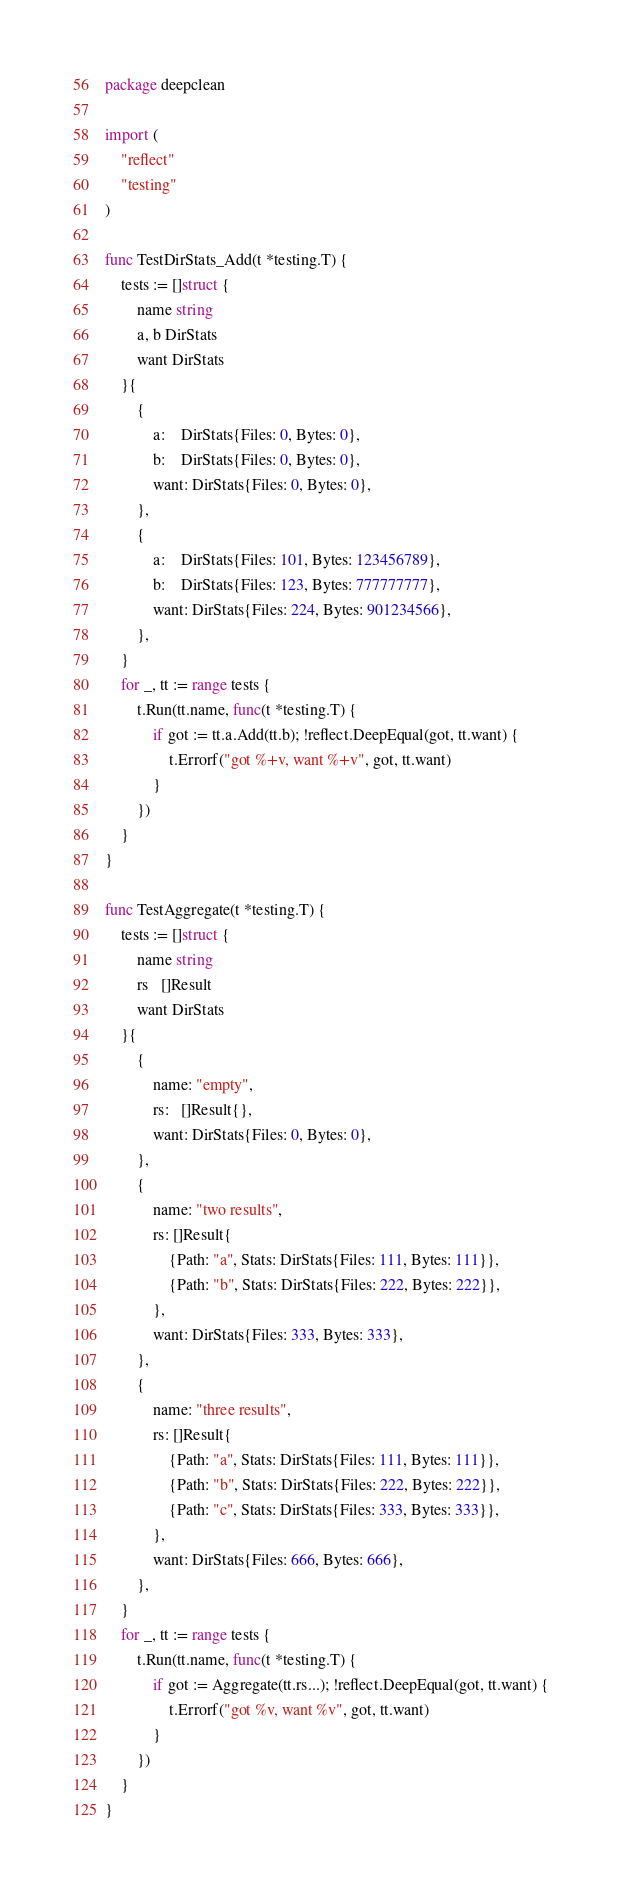<code> <loc_0><loc_0><loc_500><loc_500><_Go_>package deepclean

import (
	"reflect"
	"testing"
)

func TestDirStats_Add(t *testing.T) {
	tests := []struct {
		name string
		a, b DirStats
		want DirStats
	}{
		{
			a:    DirStats{Files: 0, Bytes: 0},
			b:    DirStats{Files: 0, Bytes: 0},
			want: DirStats{Files: 0, Bytes: 0},
		},
		{
			a:    DirStats{Files: 101, Bytes: 123456789},
			b:    DirStats{Files: 123, Bytes: 777777777},
			want: DirStats{Files: 224, Bytes: 901234566},
		},
	}
	for _, tt := range tests {
		t.Run(tt.name, func(t *testing.T) {
			if got := tt.a.Add(tt.b); !reflect.DeepEqual(got, tt.want) {
				t.Errorf("got %+v, want %+v", got, tt.want)
			}
		})
	}
}

func TestAggregate(t *testing.T) {
	tests := []struct {
		name string
		rs   []Result
		want DirStats
	}{
		{
			name: "empty",
			rs:   []Result{},
			want: DirStats{Files: 0, Bytes: 0},
		},
		{
			name: "two results",
			rs: []Result{
				{Path: "a", Stats: DirStats{Files: 111, Bytes: 111}},
				{Path: "b", Stats: DirStats{Files: 222, Bytes: 222}},
			},
			want: DirStats{Files: 333, Bytes: 333},
		},
		{
			name: "three results",
			rs: []Result{
				{Path: "a", Stats: DirStats{Files: 111, Bytes: 111}},
				{Path: "b", Stats: DirStats{Files: 222, Bytes: 222}},
				{Path: "c", Stats: DirStats{Files: 333, Bytes: 333}},
			},
			want: DirStats{Files: 666, Bytes: 666},
		},
	}
	for _, tt := range tests {
		t.Run(tt.name, func(t *testing.T) {
			if got := Aggregate(tt.rs...); !reflect.DeepEqual(got, tt.want) {
				t.Errorf("got %v, want %v", got, tt.want)
			}
		})
	}
}
</code> 